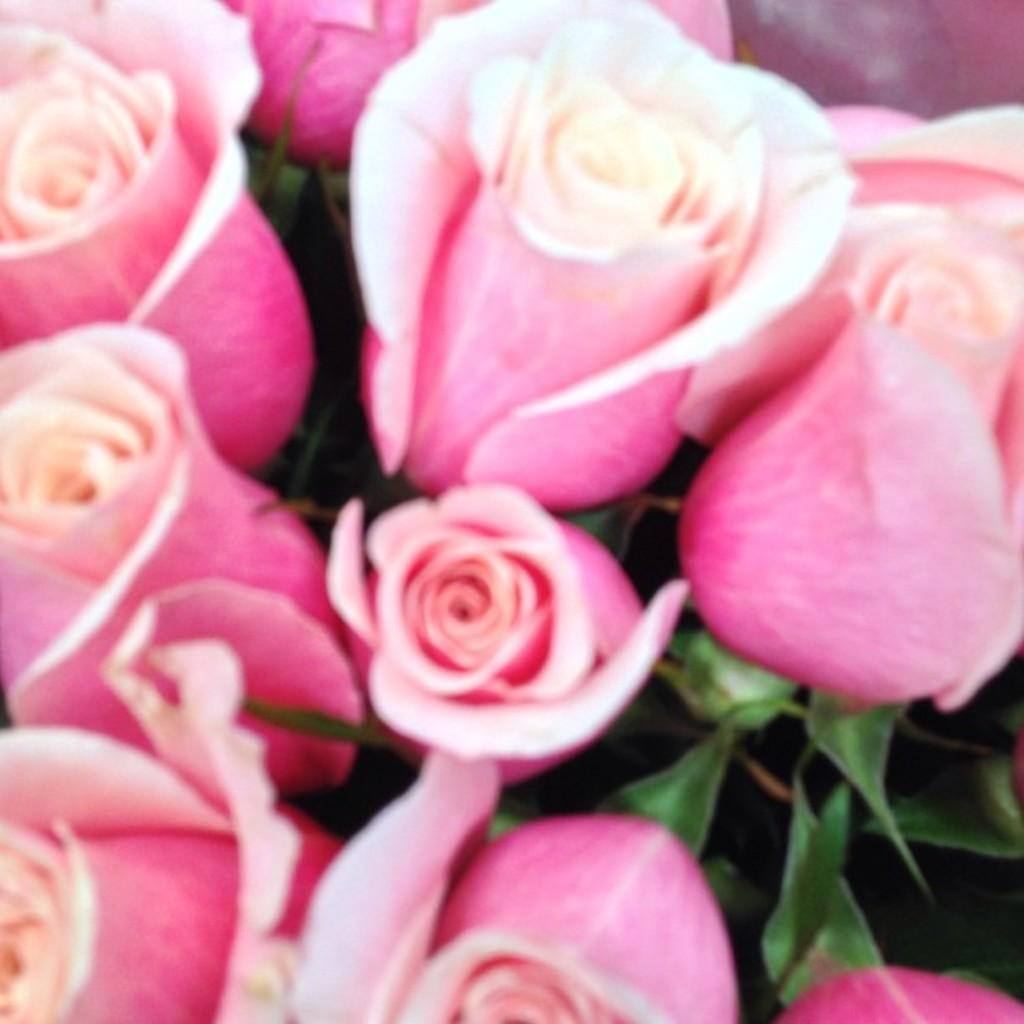What type of flowers are in the image? There are pink rose flowers in the image. What else can be seen in the image besides the flowers? There are leaves visible in the image. How many bears are sitting on the soda can in the image? There are no bears or soda cans present in the image. 